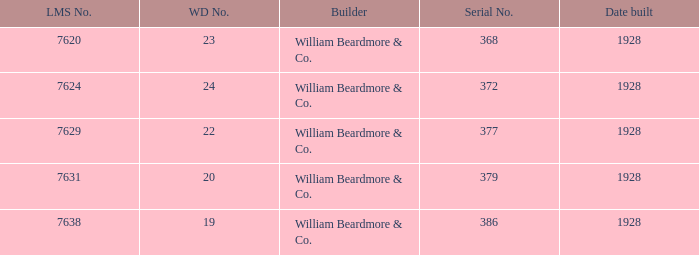Name the builder for wd number being 22 William Beardmore & Co. 